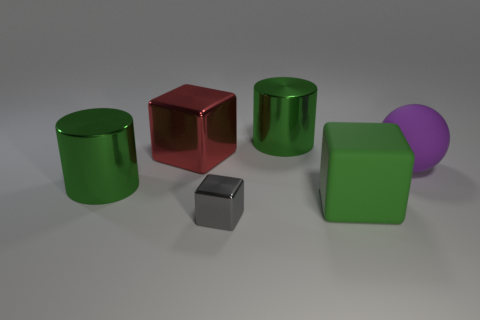How big is the metallic thing on the right side of the gray metallic thing?
Keep it short and to the point. Large. The green metallic thing to the right of the metal cylinder in front of the big metal cylinder that is on the right side of the gray object is what shape?
Make the answer very short. Cylinder. There is a big metal object that is to the left of the small gray cube and behind the matte ball; what shape is it?
Ensure brevity in your answer.  Cube. Is there a green cylinder that has the same size as the gray metal object?
Your response must be concise. No. There is a big thing that is to the right of the large green matte thing; does it have the same shape as the large red object?
Ensure brevity in your answer.  No. Is the shape of the big purple matte thing the same as the gray shiny thing?
Provide a short and direct response. No. Is there another small matte object that has the same shape as the purple thing?
Provide a succinct answer. No. There is a large object that is in front of the shiny cylinder that is in front of the purple thing; what is its shape?
Your answer should be very brief. Cube. There is a metallic thing that is in front of the matte cube; what color is it?
Your answer should be compact. Gray. There is a green thing that is the same material as the purple ball; what size is it?
Provide a short and direct response. Large. 